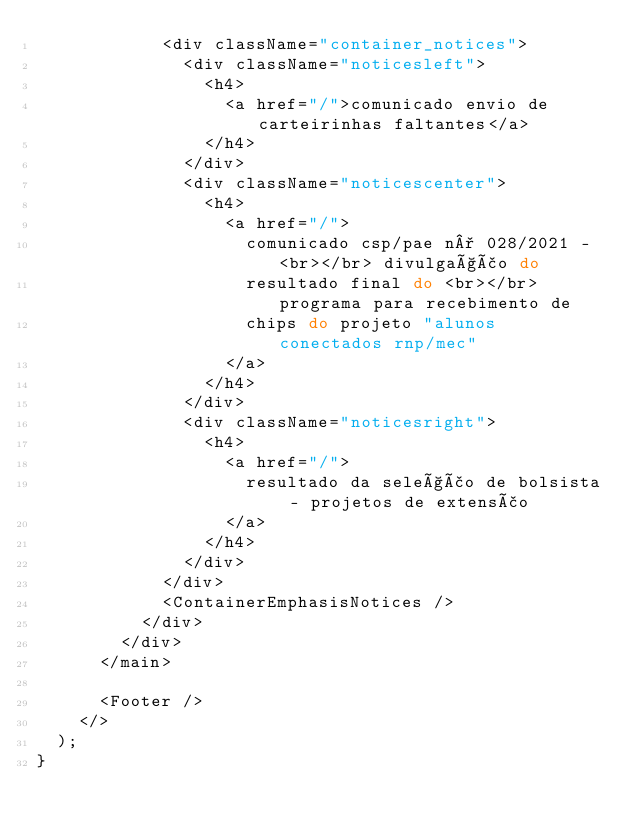Convert code to text. <code><loc_0><loc_0><loc_500><loc_500><_TypeScript_>            <div className="container_notices">
              <div className="noticesleft">
                <h4>
                  <a href="/">comunicado envio de carteirinhas faltantes</a>
                </h4>
              </div>
              <div className="noticescenter">
                <h4>
                  <a href="/">
                    comunicado csp/pae n° 028/2021 - <br></br> divulgação do
                    resultado final do <br></br> programa para recebimento de
                    chips do projeto "alunos conectados rnp/mec"
                  </a>
                </h4>
              </div>
              <div className="noticesright">
                <h4>
                  <a href="/">
                    resultado da seleção de bolsista - projetos de extensão
                  </a>
                </h4>
              </div>
            </div>
            <ContainerEmphasisNotices />
          </div>
        </div>
      </main>

      <Footer />
    </>
  );
}
</code> 